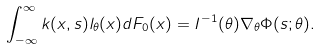Convert formula to latex. <formula><loc_0><loc_0><loc_500><loc_500>\int _ { - \infty } ^ { \infty } k ( x , s ) l _ { \theta } ( x ) d F _ { 0 } ( x ) = I ^ { - 1 } ( \theta ) \nabla _ { \theta } \Phi ( s ; \theta ) .</formula> 